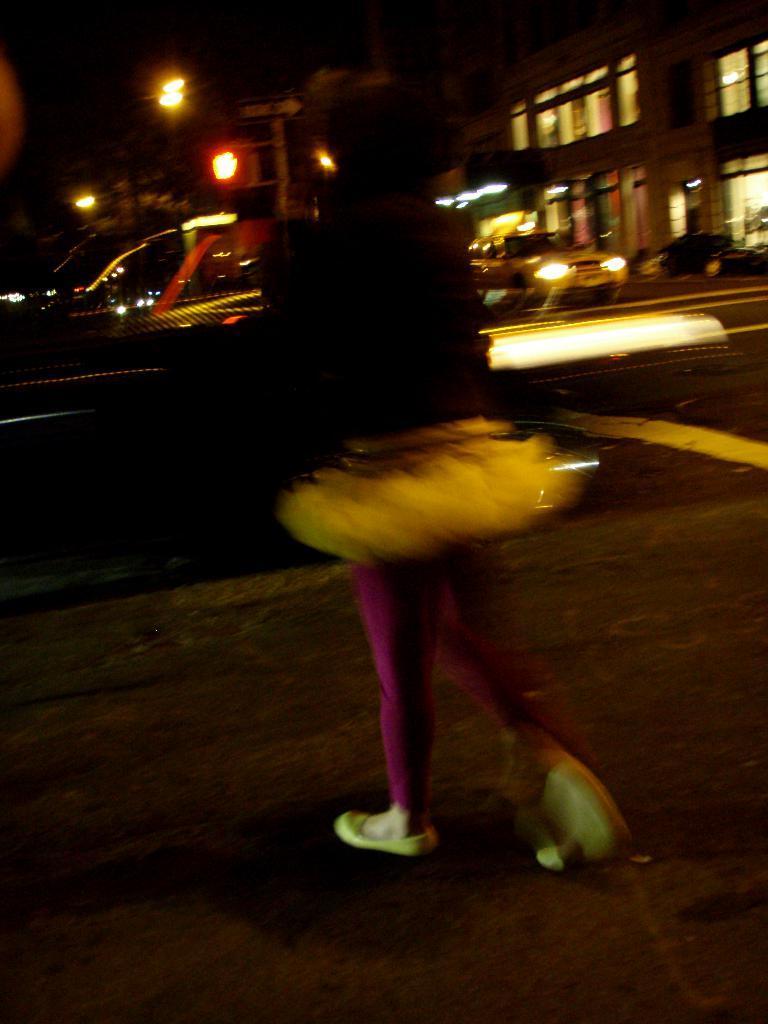Can you describe this image briefly? In this image I can see few buildings, lights, windows, few vehicles and one person is standing. The image is dark. 